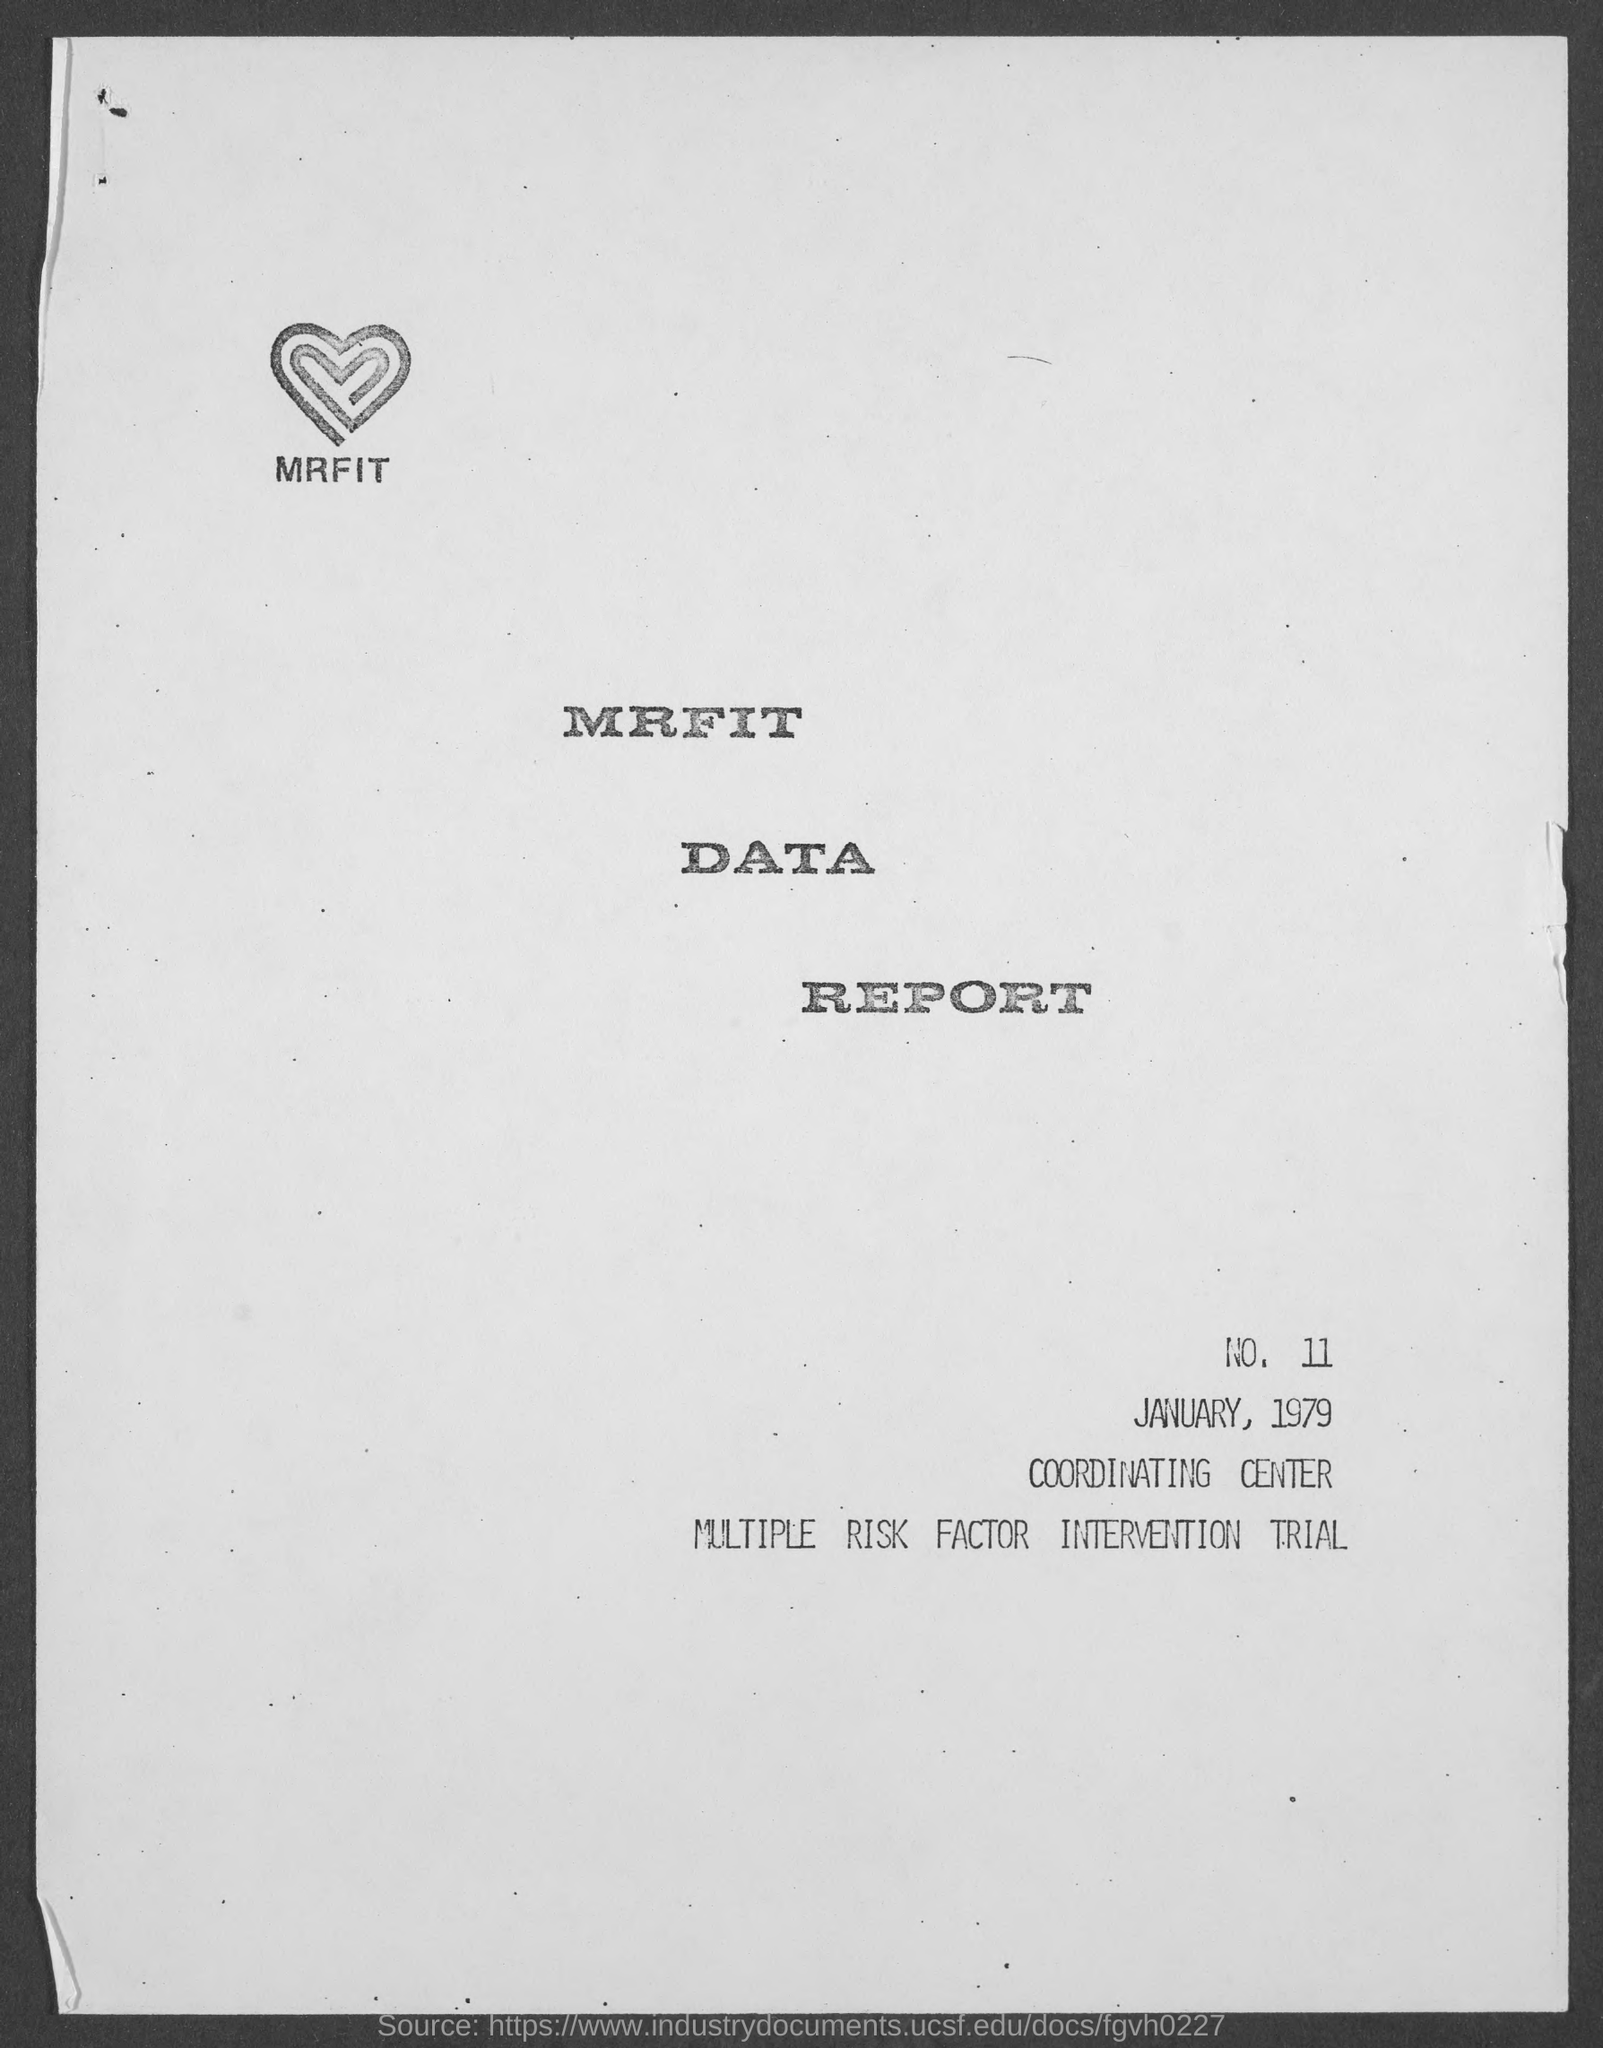List a handful of essential elements in this visual. The date mentioned in the report is January 1979. MRFIT stands for Multiple Risk Factor Intervention Trial. 